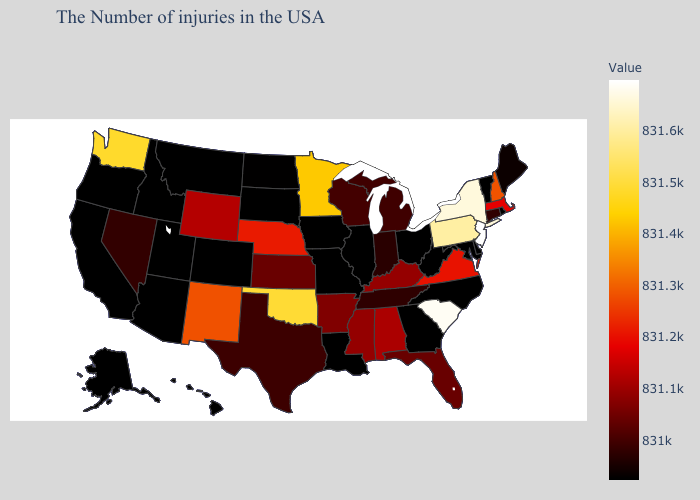Among the states that border Alabama , which have the highest value?
Answer briefly. Mississippi. Does Connecticut have the lowest value in the Northeast?
Short answer required. No. Does Hawaii have the lowest value in the USA?
Answer briefly. Yes. Does Indiana have the lowest value in the MidWest?
Write a very short answer. No. Which states have the lowest value in the MidWest?
Give a very brief answer. Ohio, Illinois, Missouri, Iowa, South Dakota. Among the states that border New Jersey , does Pennsylvania have the lowest value?
Answer briefly. No. 